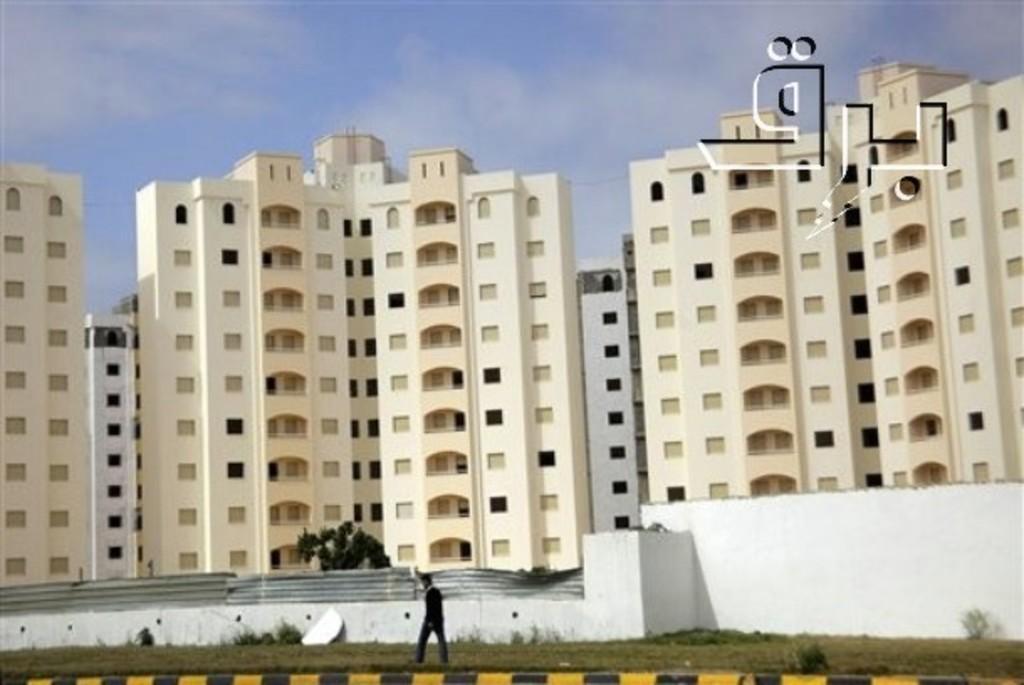In one or two sentences, can you explain what this image depicts? At the bottom of this image, there is a person walking on a ground, on which there is grass. Beside this person, there is a white wall. In the background, there are buildings, trees and there are clouds in the sky. 